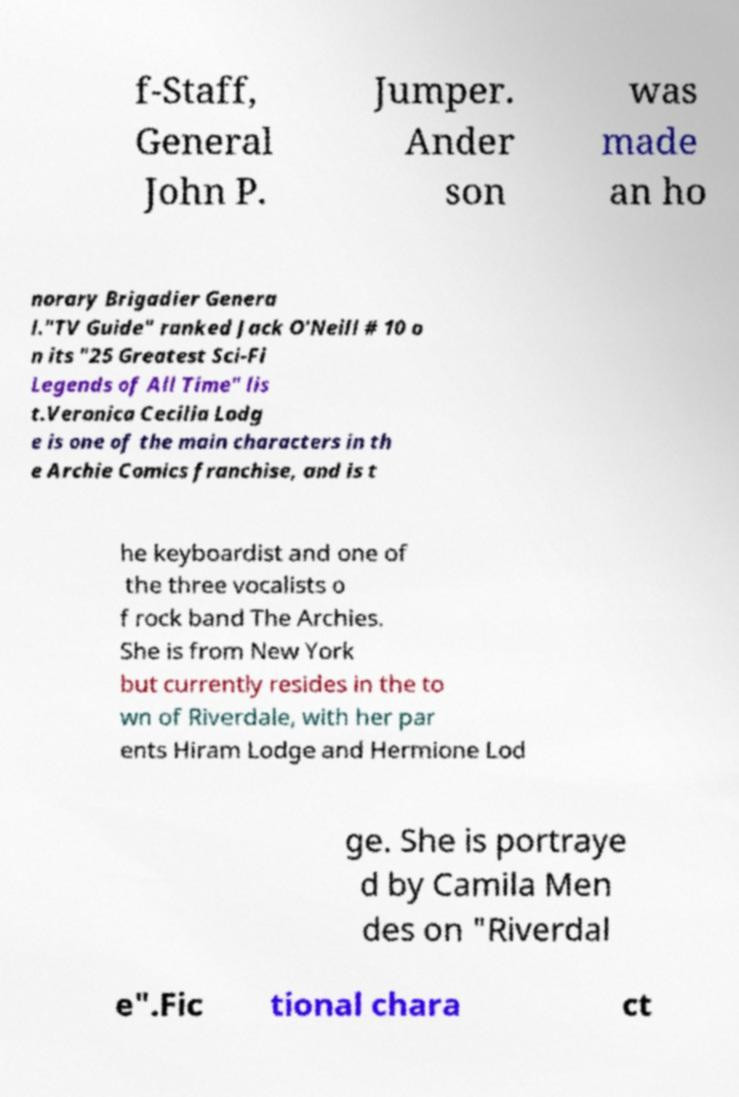Please read and relay the text visible in this image. What does it say? f-Staff, General John P. Jumper. Ander son was made an ho norary Brigadier Genera l."TV Guide" ranked Jack O'Neill # 10 o n its "25 Greatest Sci-Fi Legends of All Time" lis t.Veronica Cecilia Lodg e is one of the main characters in th e Archie Comics franchise, and is t he keyboardist and one of the three vocalists o f rock band The Archies. She is from New York but currently resides in the to wn of Riverdale, with her par ents Hiram Lodge and Hermione Lod ge. She is portraye d by Camila Men des on "Riverdal e".Fic tional chara ct 